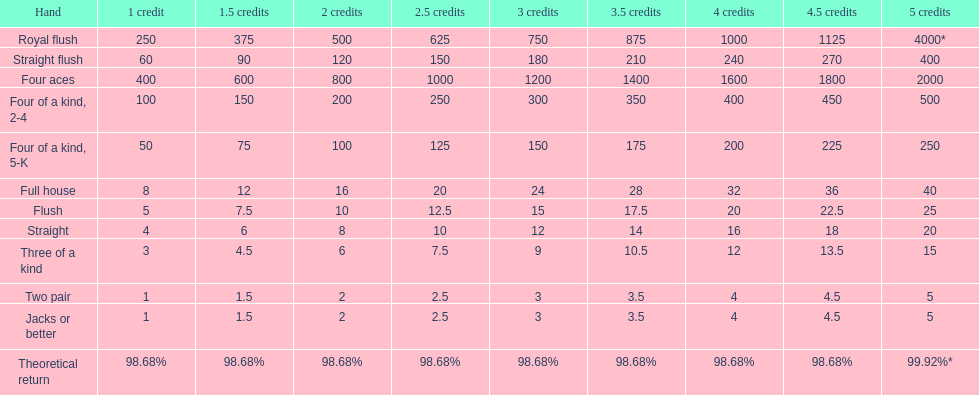Which is a higher standing hand: a straight or a flush? Flush. Help me parse the entirety of this table. {'header': ['Hand', '1 credit', '1.5 credits', '2 credits', '2.5 credits', '3 credits', '3.5 credits', '4 credits', '4.5 credits', '5 credits'], 'rows': [['Royal flush', '250', '375', '500', '625', '750', '875', '1000', '1125', '4000*'], ['Straight flush', '60', '90', '120', '150', '180', '210', '240', '270', '400'], ['Four aces', '400', '600', '800', '1000', '1200', '1400', '1600', '1800', '2000'], ['Four of a kind, 2-4', '100', '150', '200', '250', '300', '350', '400', '450', '500'], ['Four of a kind, 5-K', '50', '75', '100', '125', '150', '175', '200', '225', '250'], ['Full house', '8', '12', '16', '20', '24', '28', '32', '36', '40'], ['Flush', '5', '7.5', '10', '12.5', '15', '17.5', '20', '22.5', '25'], ['Straight', '4', '6', '8', '10', '12', '14', '16', '18', '20'], ['Three of a kind', '3', '4.5', '6', '7.5', '9', '10.5', '12', '13.5', '15'], ['Two pair', '1', '1.5', '2', '2.5', '3', '3.5', '4', '4.5', '5'], ['Jacks or better', '1', '1.5', '2', '2.5', '3', '3.5', '4', '4.5', '5'], ['Theoretical return', '98.68%', '98.68%', '98.68%', '98.68%', '98.68%', '98.68%', '98.68%', '98.68%', '99.92%*']]} 